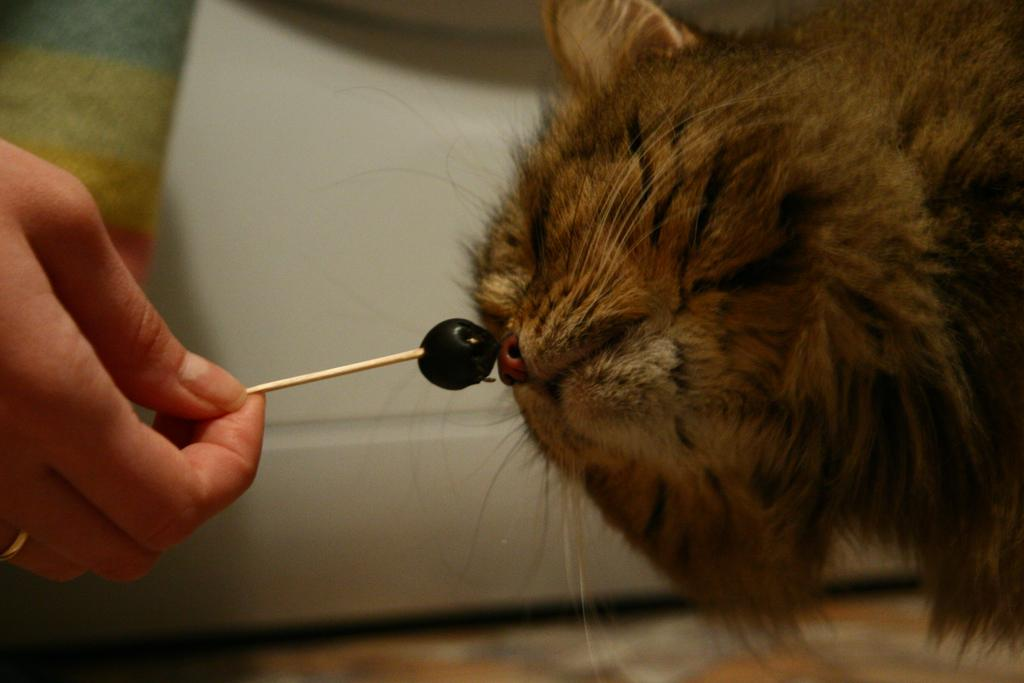What type of animal is in the image? The type of animal cannot be determined from the provided facts. What is the person doing in the image? The person is holding a needle in their hand. Can you describe the background of the image? The background of the image is blurry. What type of skirt is the person wearing in the image? There is no information about a skirt in the image or the provided facts. 